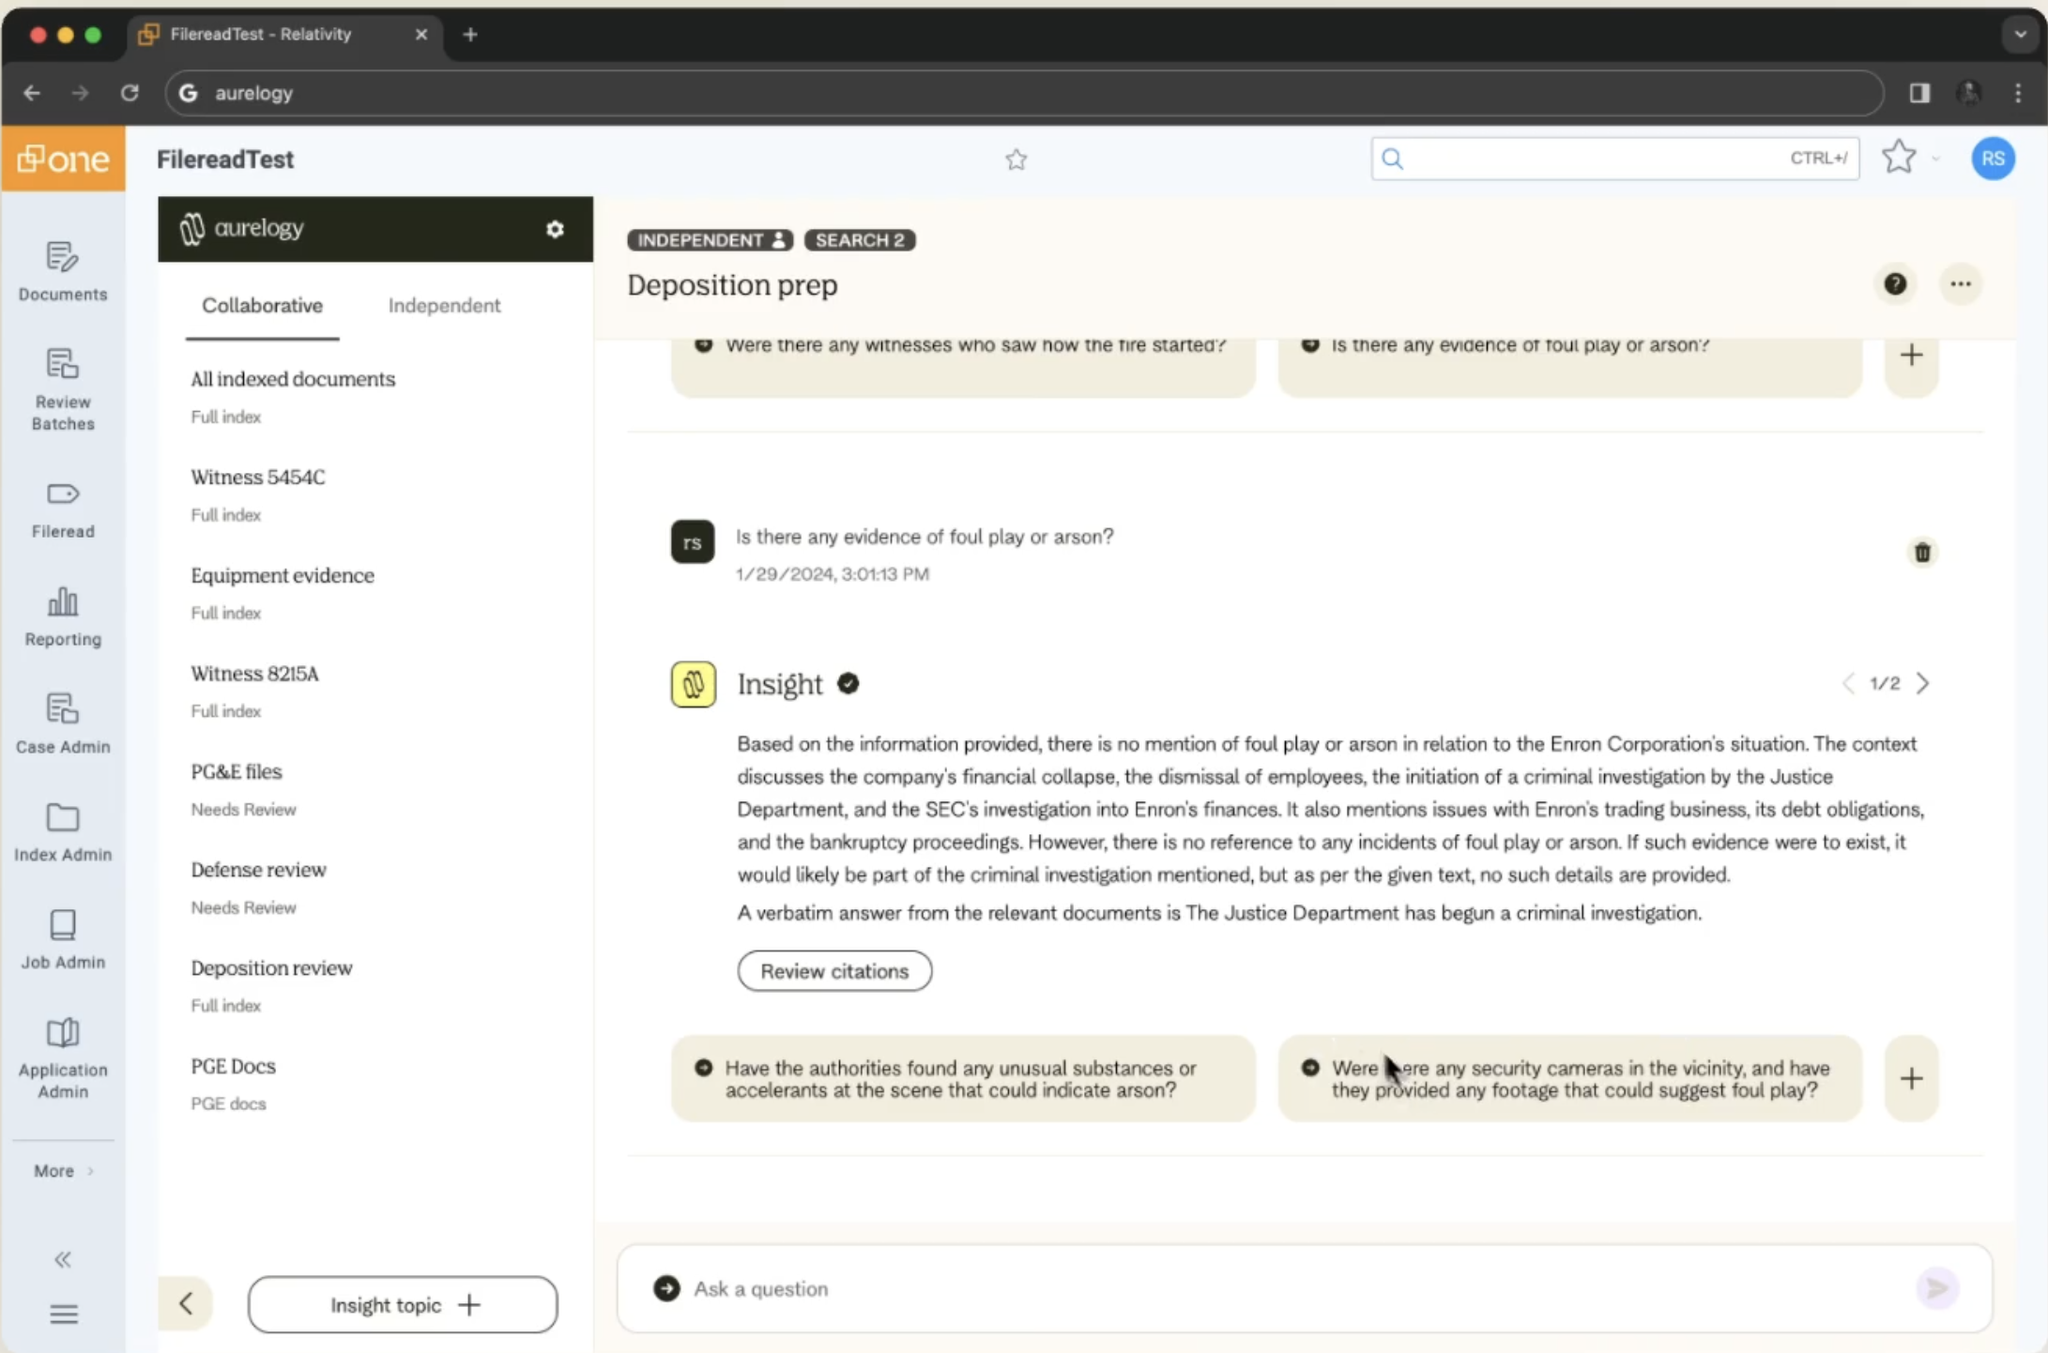this is a screenshot of a website that my friend wants me to reproduce. Describe it in such a way that I can place your response as a prompt for an llm to build out the code
 This image shows a web application interface for a legal document review and analysis tool called "Relativity" by a company named Aurelogy. The interface has a layout typical of modern web applications:

1. A top navigation bar with browser controls and a search field.
2. A left sidebar with various menu items like "Documents", "Review Batches", "Fileread", "Reporting", etc.
3. The main content area is divided into three columns:
   - Left: A list of document categories or folders
   - Middle: A section titled "Deposition prep" with question cards
   - Right: An "Insight" panel showing an AI-generated response

The main content focuses on a "Deposition prep" section, which appears to be using AI to assist with legal case preparation. There are question cards visible, such as "Were there any witnesses who saw how the fire started?" and "Is there any evidence of foul play or arson?"

The right panel shows an AI-generated response addressing the question about evidence of foul play or arson, referencing the Enron Corporation's situation and mentioning various aspects of the case like financial collapse, criminal investigation, and SEC involvement.

The interface uses a clean, modern design with a white background, subtle shadows for depth, and a color scheme primarily of white, light blue, and dark text. The layout is responsive and modular, suggesting it's built with modern web technologies.

To recreate this, you'd need to design a multi-pane layout with a top navbar, left sidebar for navigation, and a three-column main content area. You'd also need to implement functionality for displaying and interacting with question cards, as well as an AI response system that can generate insights based on the selected questions and available document data. 